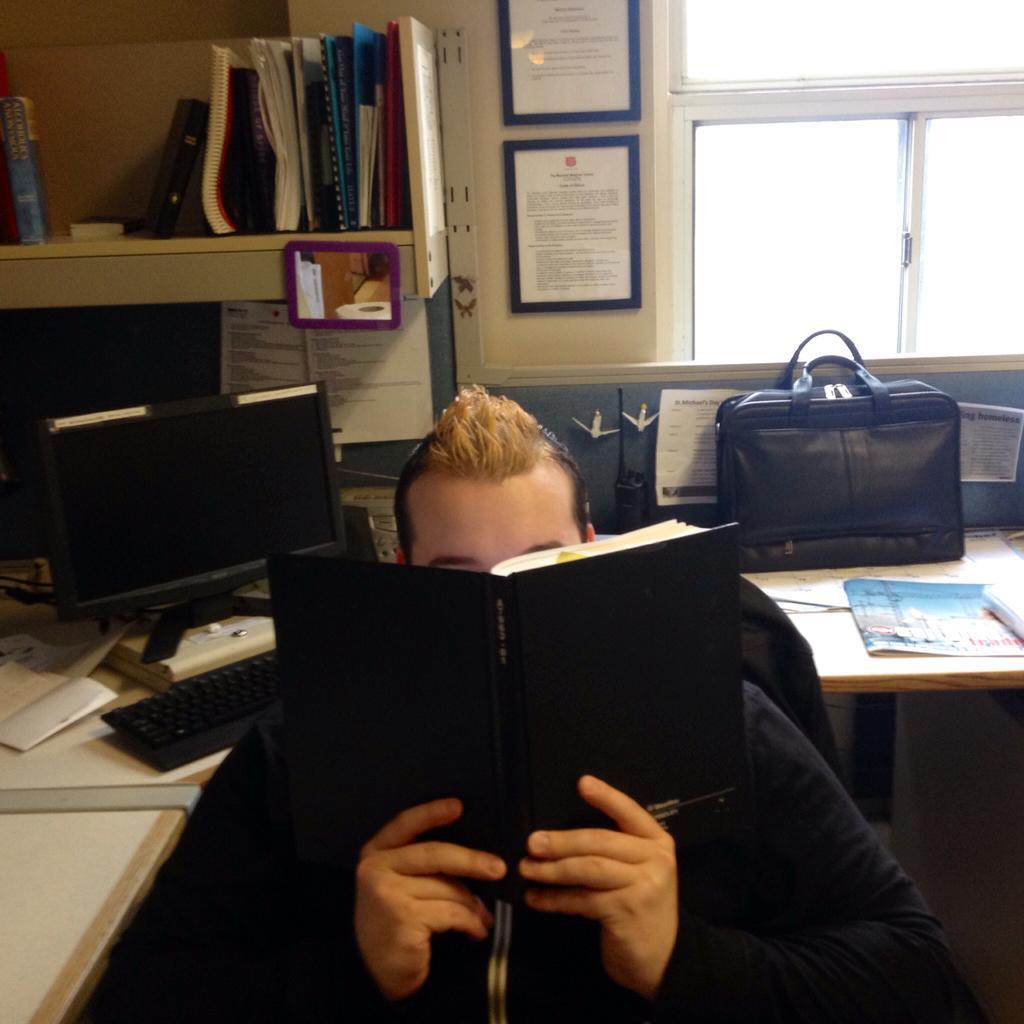Could you give a brief overview of what you see in this image? There is a man who is holding a book with his hands. This is table. On the table there is a monitor, keyboard, bag, and papers. This is rack and there are some books. Here we can see a window and these are the frames. 